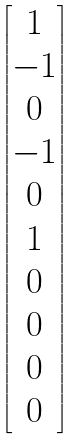<formula> <loc_0><loc_0><loc_500><loc_500>\begin{bmatrix} 1 \\ - 1 \\ 0 \\ - 1 \\ 0 \\ 1 \\ 0 \\ 0 \\ 0 \\ 0 \end{bmatrix}</formula> 